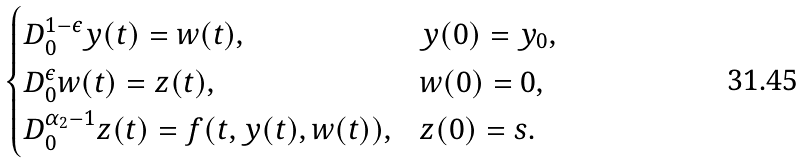<formula> <loc_0><loc_0><loc_500><loc_500>\begin{cases} D ^ { 1 - \epsilon } _ { 0 } y ( t ) = w ( t ) , & y ( 0 ) = y _ { 0 } , \\ D ^ { \epsilon } _ { 0 } w ( t ) = z ( t ) , & w ( 0 ) = 0 , \\ D ^ { \alpha _ { 2 } - 1 } _ { 0 } z ( t ) = f ( t , y ( t ) , w ( t ) ) , & z ( 0 ) = s . \end{cases}</formula> 